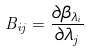<formula> <loc_0><loc_0><loc_500><loc_500>B _ { i j } = \frac { \partial \beta _ { \lambda _ { i } } } { \partial \lambda _ { j } }</formula> 